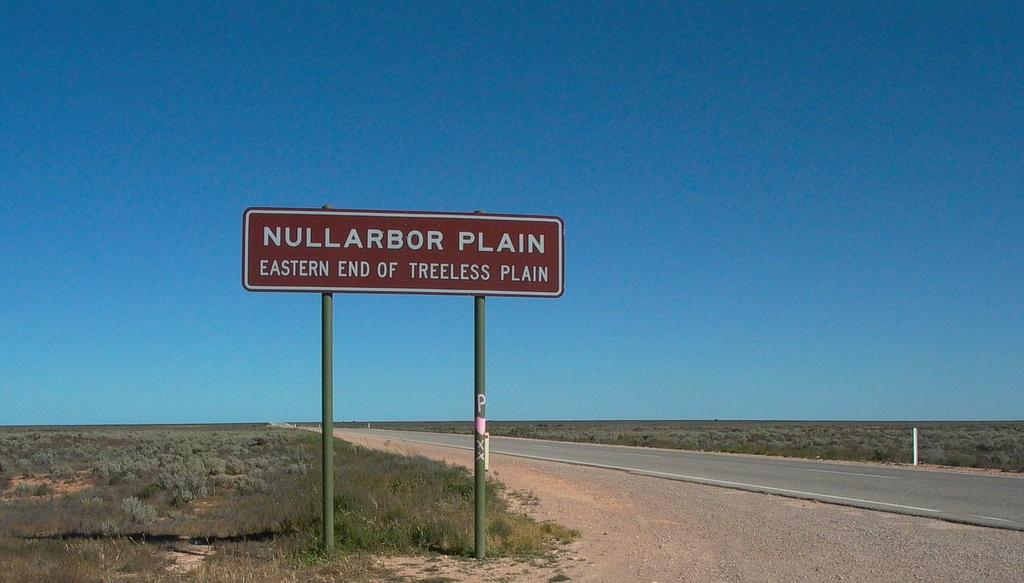<image>
Create a compact narrative representing the image presented. A road on a freeway with a sign along it that reads Nullarbor Plain Eastern End of Treeless Plain 